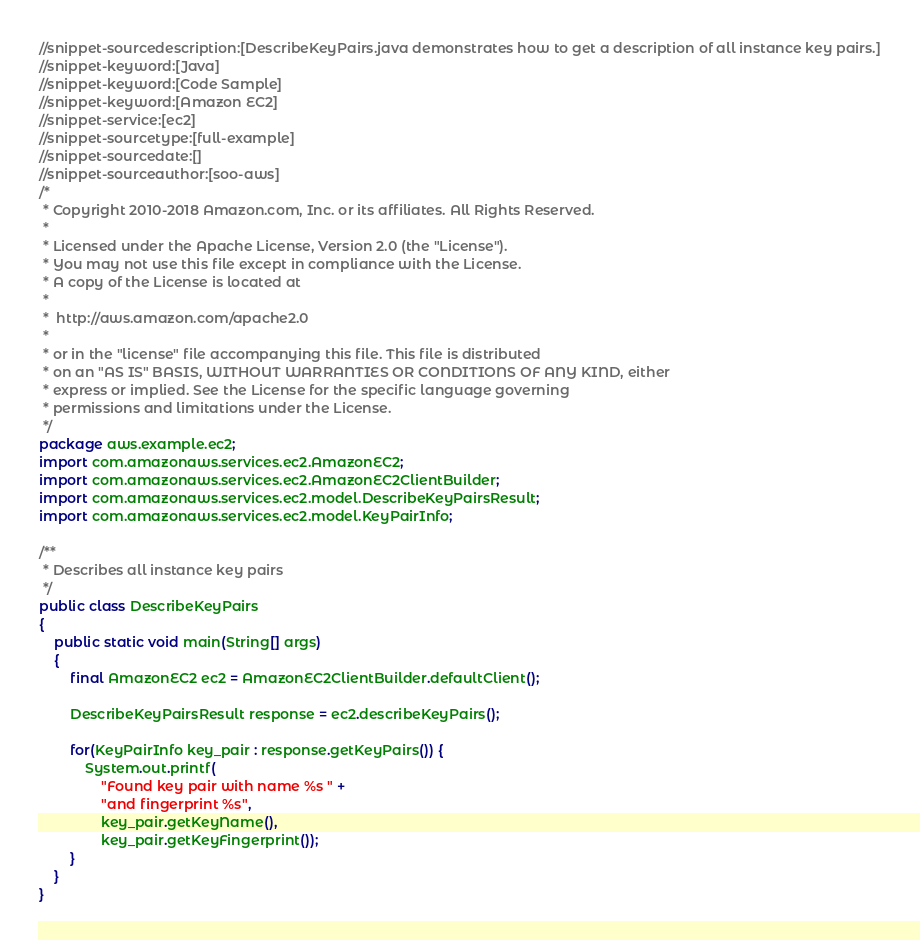Convert code to text. <code><loc_0><loc_0><loc_500><loc_500><_Java_>//snippet-sourcedescription:[DescribeKeyPairs.java demonstrates how to get a description of all instance key pairs.]
//snippet-keyword:[Java]
//snippet-keyword:[Code Sample]
//snippet-keyword:[Amazon EC2]
//snippet-service:[ec2]
//snippet-sourcetype:[full-example]
//snippet-sourcedate:[]
//snippet-sourceauthor:[soo-aws]
/*
 * Copyright 2010-2018 Amazon.com, Inc. or its affiliates. All Rights Reserved.
 *
 * Licensed under the Apache License, Version 2.0 (the "License").
 * You may not use this file except in compliance with the License.
 * A copy of the License is located at
 *
 *  http://aws.amazon.com/apache2.0
 *
 * or in the "license" file accompanying this file. This file is distributed
 * on an "AS IS" BASIS, WITHOUT WARRANTIES OR CONDITIONS OF ANY KIND, either
 * express or implied. See the License for the specific language governing
 * permissions and limitations under the License.
 */
package aws.example.ec2;
import com.amazonaws.services.ec2.AmazonEC2;
import com.amazonaws.services.ec2.AmazonEC2ClientBuilder;
import com.amazonaws.services.ec2.model.DescribeKeyPairsResult;
import com.amazonaws.services.ec2.model.KeyPairInfo;

/**
 * Describes all instance key pairs
 */
public class DescribeKeyPairs
{
    public static void main(String[] args)
    {
        final AmazonEC2 ec2 = AmazonEC2ClientBuilder.defaultClient();

        DescribeKeyPairsResult response = ec2.describeKeyPairs();

        for(KeyPairInfo key_pair : response.getKeyPairs()) {
            System.out.printf(
                "Found key pair with name %s " +
                "and fingerprint %s",
                key_pair.getKeyName(),
                key_pair.getKeyFingerprint());
        }
    }
}
</code> 